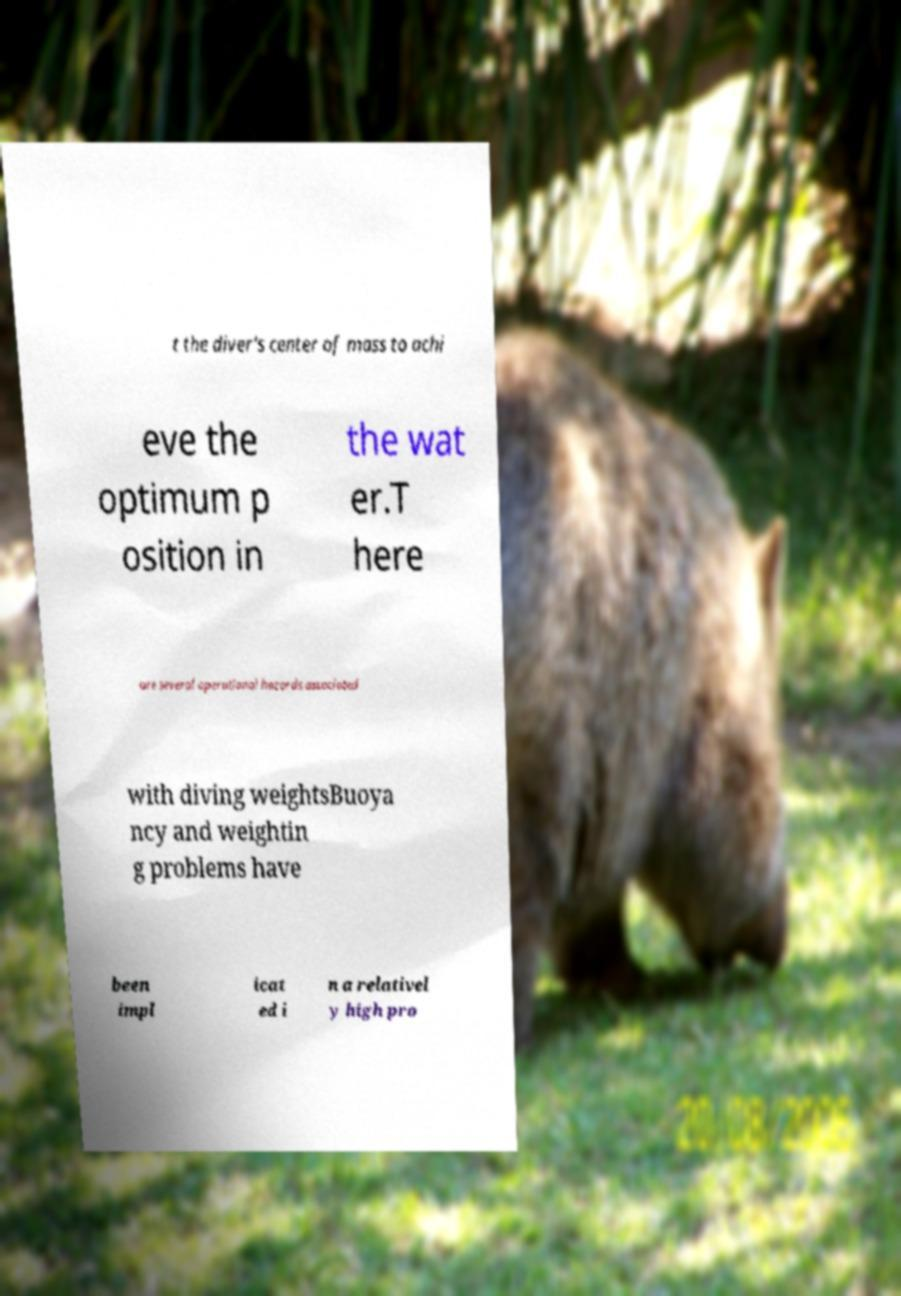Can you read and provide the text displayed in the image?This photo seems to have some interesting text. Can you extract and type it out for me? t the diver's center of mass to achi eve the optimum p osition in the wat er.T here are several operational hazards associated with diving weightsBuoya ncy and weightin g problems have been impl icat ed i n a relativel y high pro 